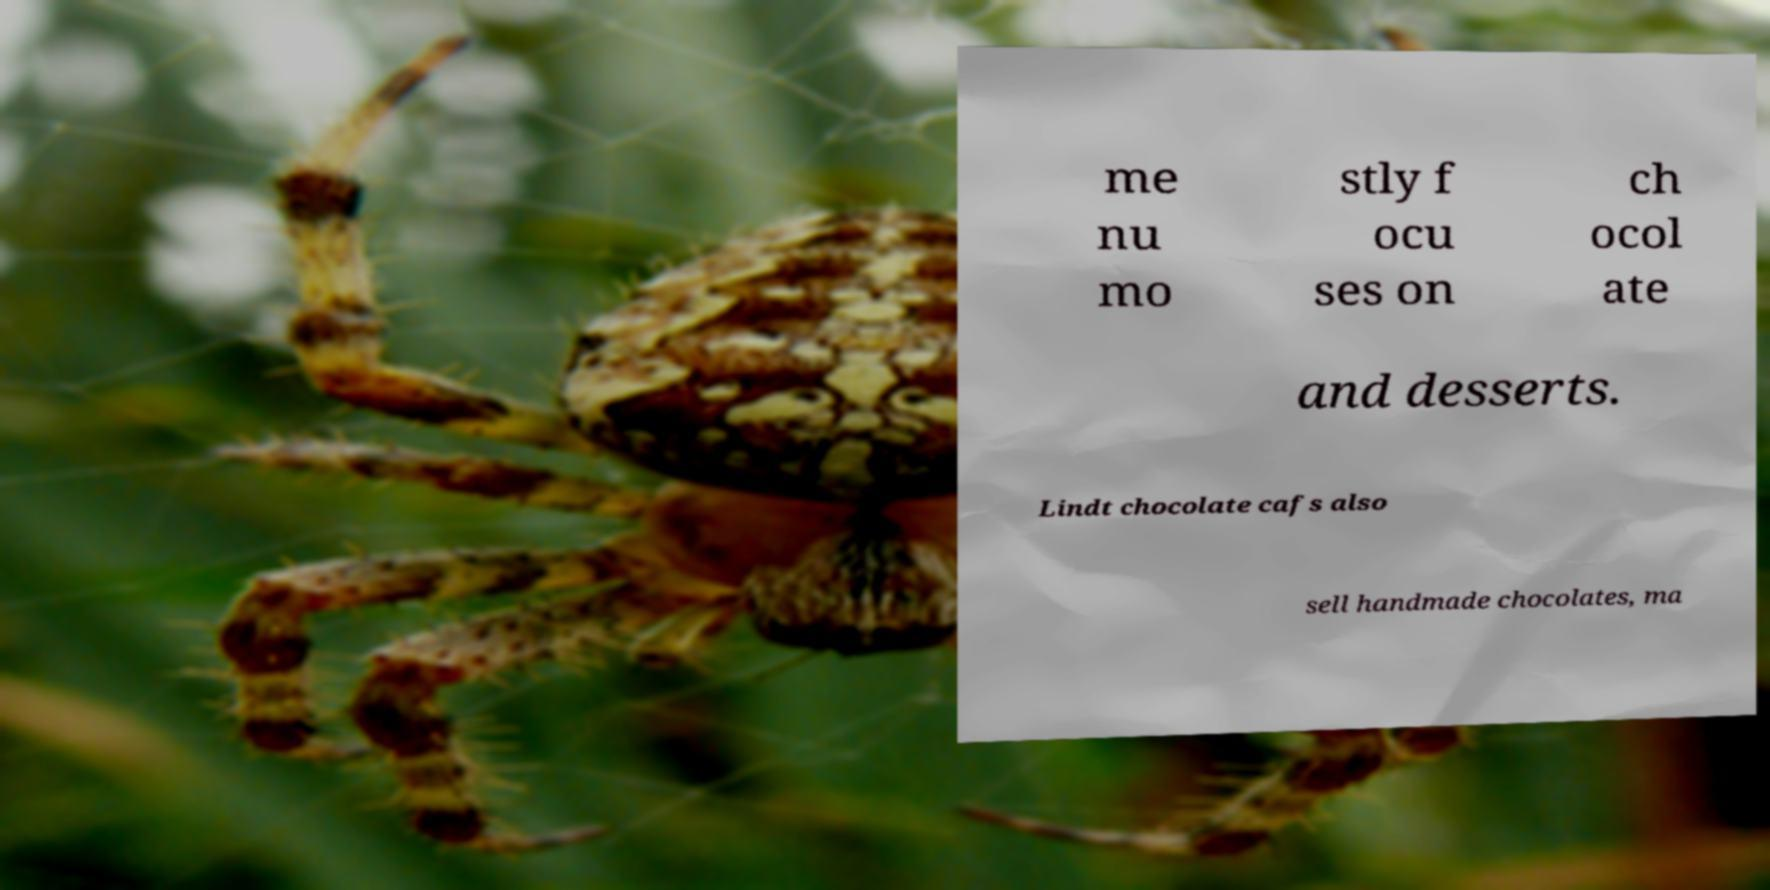Could you assist in decoding the text presented in this image and type it out clearly? me nu mo stly f ocu ses on ch ocol ate and desserts. Lindt chocolate cafs also sell handmade chocolates, ma 